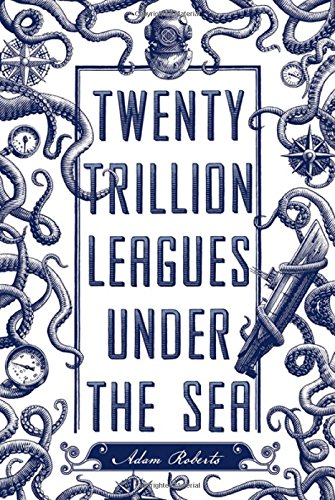What is the title of this book? The intriguing title of the book is 'Twenty Trillion Leagues Under the Sea,' which seems to pay homage to Jules Verne's classic while promising an exponentially grander adventure. 